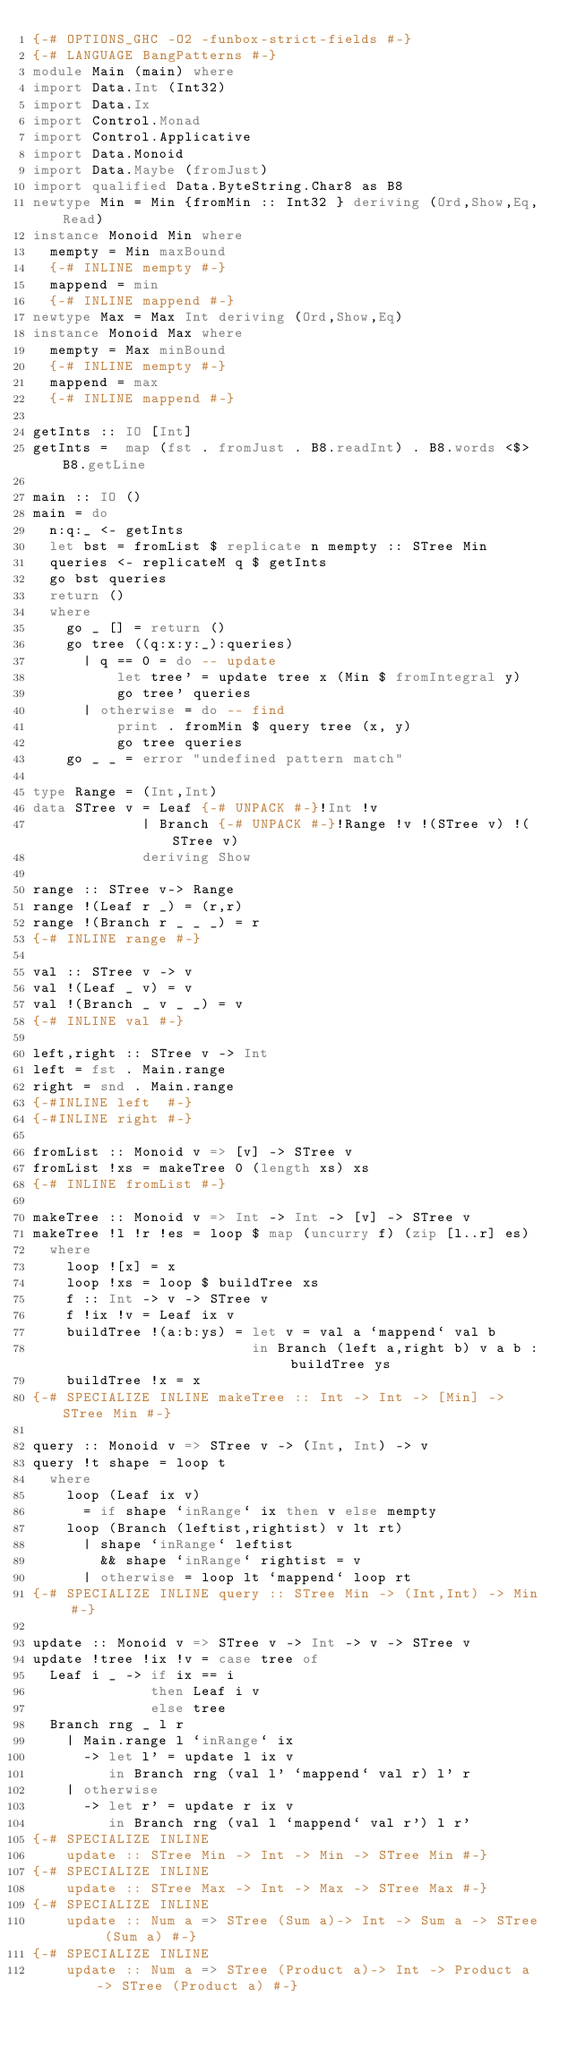<code> <loc_0><loc_0><loc_500><loc_500><_Haskell_>{-# OPTIONS_GHC -O2 -funbox-strict-fields #-}
{-# LANGUAGE BangPatterns #-}
module Main (main) where
import Data.Int (Int32)
import Data.Ix
import Control.Monad
import Control.Applicative
import Data.Monoid
import Data.Maybe (fromJust)
import qualified Data.ByteString.Char8 as B8
newtype Min = Min {fromMin :: Int32 } deriving (Ord,Show,Eq,Read)
instance Monoid Min where
  mempty = Min maxBound
  {-# INLINE mempty #-}
  mappend = min
  {-# INLINE mappend #-}
newtype Max = Max Int deriving (Ord,Show,Eq)
instance Monoid Max where
  mempty = Max minBound
  {-# INLINE mempty #-}
  mappend = max
  {-# INLINE mappend #-}

getInts :: IO [Int]
getInts =  map (fst . fromJust . B8.readInt) . B8.words <$> B8.getLine

main :: IO ()
main = do
  n:q:_ <- getInts
  let bst = fromList $ replicate n mempty :: STree Min
  queries <- replicateM q $ getInts
  go bst queries
  return ()
  where
    go _ [] = return ()
    go tree ((q:x:y:_):queries)
      | q == 0 = do -- update
          let tree' = update tree x (Min $ fromIntegral y)
          go tree' queries
      | otherwise = do -- find
          print . fromMin $ query tree (x, y)
          go tree queries
    go _ _ = error "undefined pattern match"

type Range = (Int,Int)
data STree v = Leaf {-# UNPACK #-}!Int !v
             | Branch {-# UNPACK #-}!Range !v !(STree v) !(STree v)
             deriving Show

range :: STree v-> Range
range !(Leaf r _) = (r,r)
range !(Branch r _ _ _) = r
{-# INLINE range #-}

val :: STree v -> v
val !(Leaf _ v) = v
val !(Branch _ v _ _) = v
{-# INLINE val #-}

left,right :: STree v -> Int
left = fst . Main.range
right = snd . Main.range
{-#INLINE left  #-}
{-#INLINE right #-}

fromList :: Monoid v => [v] -> STree v
fromList !xs = makeTree 0 (length xs) xs
{-# INLINE fromList #-}

makeTree :: Monoid v => Int -> Int -> [v] -> STree v
makeTree !l !r !es = loop $ map (uncurry f) (zip [l..r] es)
  where
    loop ![x] = x
    loop !xs = loop $ buildTree xs
    f :: Int -> v -> STree v
    f !ix !v = Leaf ix v
    buildTree !(a:b:ys) = let v = val a `mappend` val b
                          in Branch (left a,right b) v a b : buildTree ys
    buildTree !x = x
{-# SPECIALIZE INLINE makeTree :: Int -> Int -> [Min] -> STree Min #-}

query :: Monoid v => STree v -> (Int, Int) -> v
query !t shape = loop t
  where
    loop (Leaf ix v)
      = if shape `inRange` ix then v else mempty
    loop (Branch (leftist,rightist) v lt rt)
      | shape `inRange` leftist
        && shape `inRange` rightist = v
      | otherwise = loop lt `mappend` loop rt
{-# SPECIALIZE INLINE query :: STree Min -> (Int,Int) -> Min #-}

update :: Monoid v => STree v -> Int -> v -> STree v
update !tree !ix !v = case tree of
  Leaf i _ -> if ix == i
              then Leaf i v
              else tree
  Branch rng _ l r
    | Main.range l `inRange` ix
      -> let l' = update l ix v
         in Branch rng (val l' `mappend` val r) l' r
    | otherwise
      -> let r' = update r ix v
         in Branch rng (val l `mappend` val r') l r'
{-# SPECIALIZE INLINE
    update :: STree Min -> Int -> Min -> STree Min #-}
{-# SPECIALIZE INLINE
    update :: STree Max -> Int -> Max -> STree Max #-}
{-# SPECIALIZE INLINE
    update :: Num a => STree (Sum a)-> Int -> Sum a -> STree (Sum a) #-}
{-# SPECIALIZE INLINE
    update :: Num a => STree (Product a)-> Int -> Product a -> STree (Product a) #-}</code> 